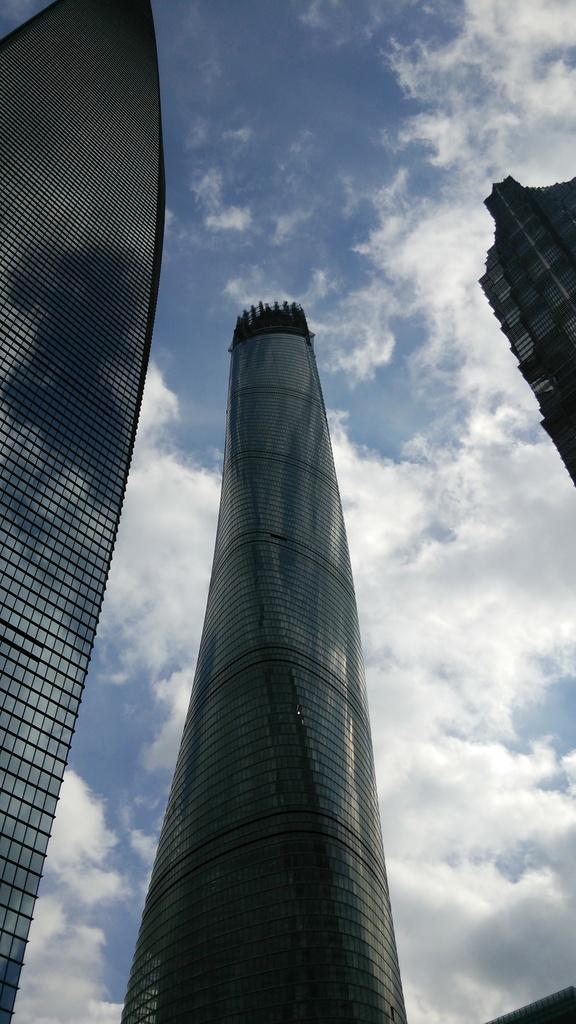What structures are present in the image? There are buildings in the image. What part of the natural environment is visible in the image? The sky is visible in the image. What can be seen in the sky in the image? There are clouds in the sky. What type of apparatus is being used to prepare the feast in the image? There is no feast or apparatus present in the image; it only features buildings and clouds in the sky. What type of collar is visible on any of the buildings in the image? There is no collar present in the image; it only features buildings and clouds in the sky. 